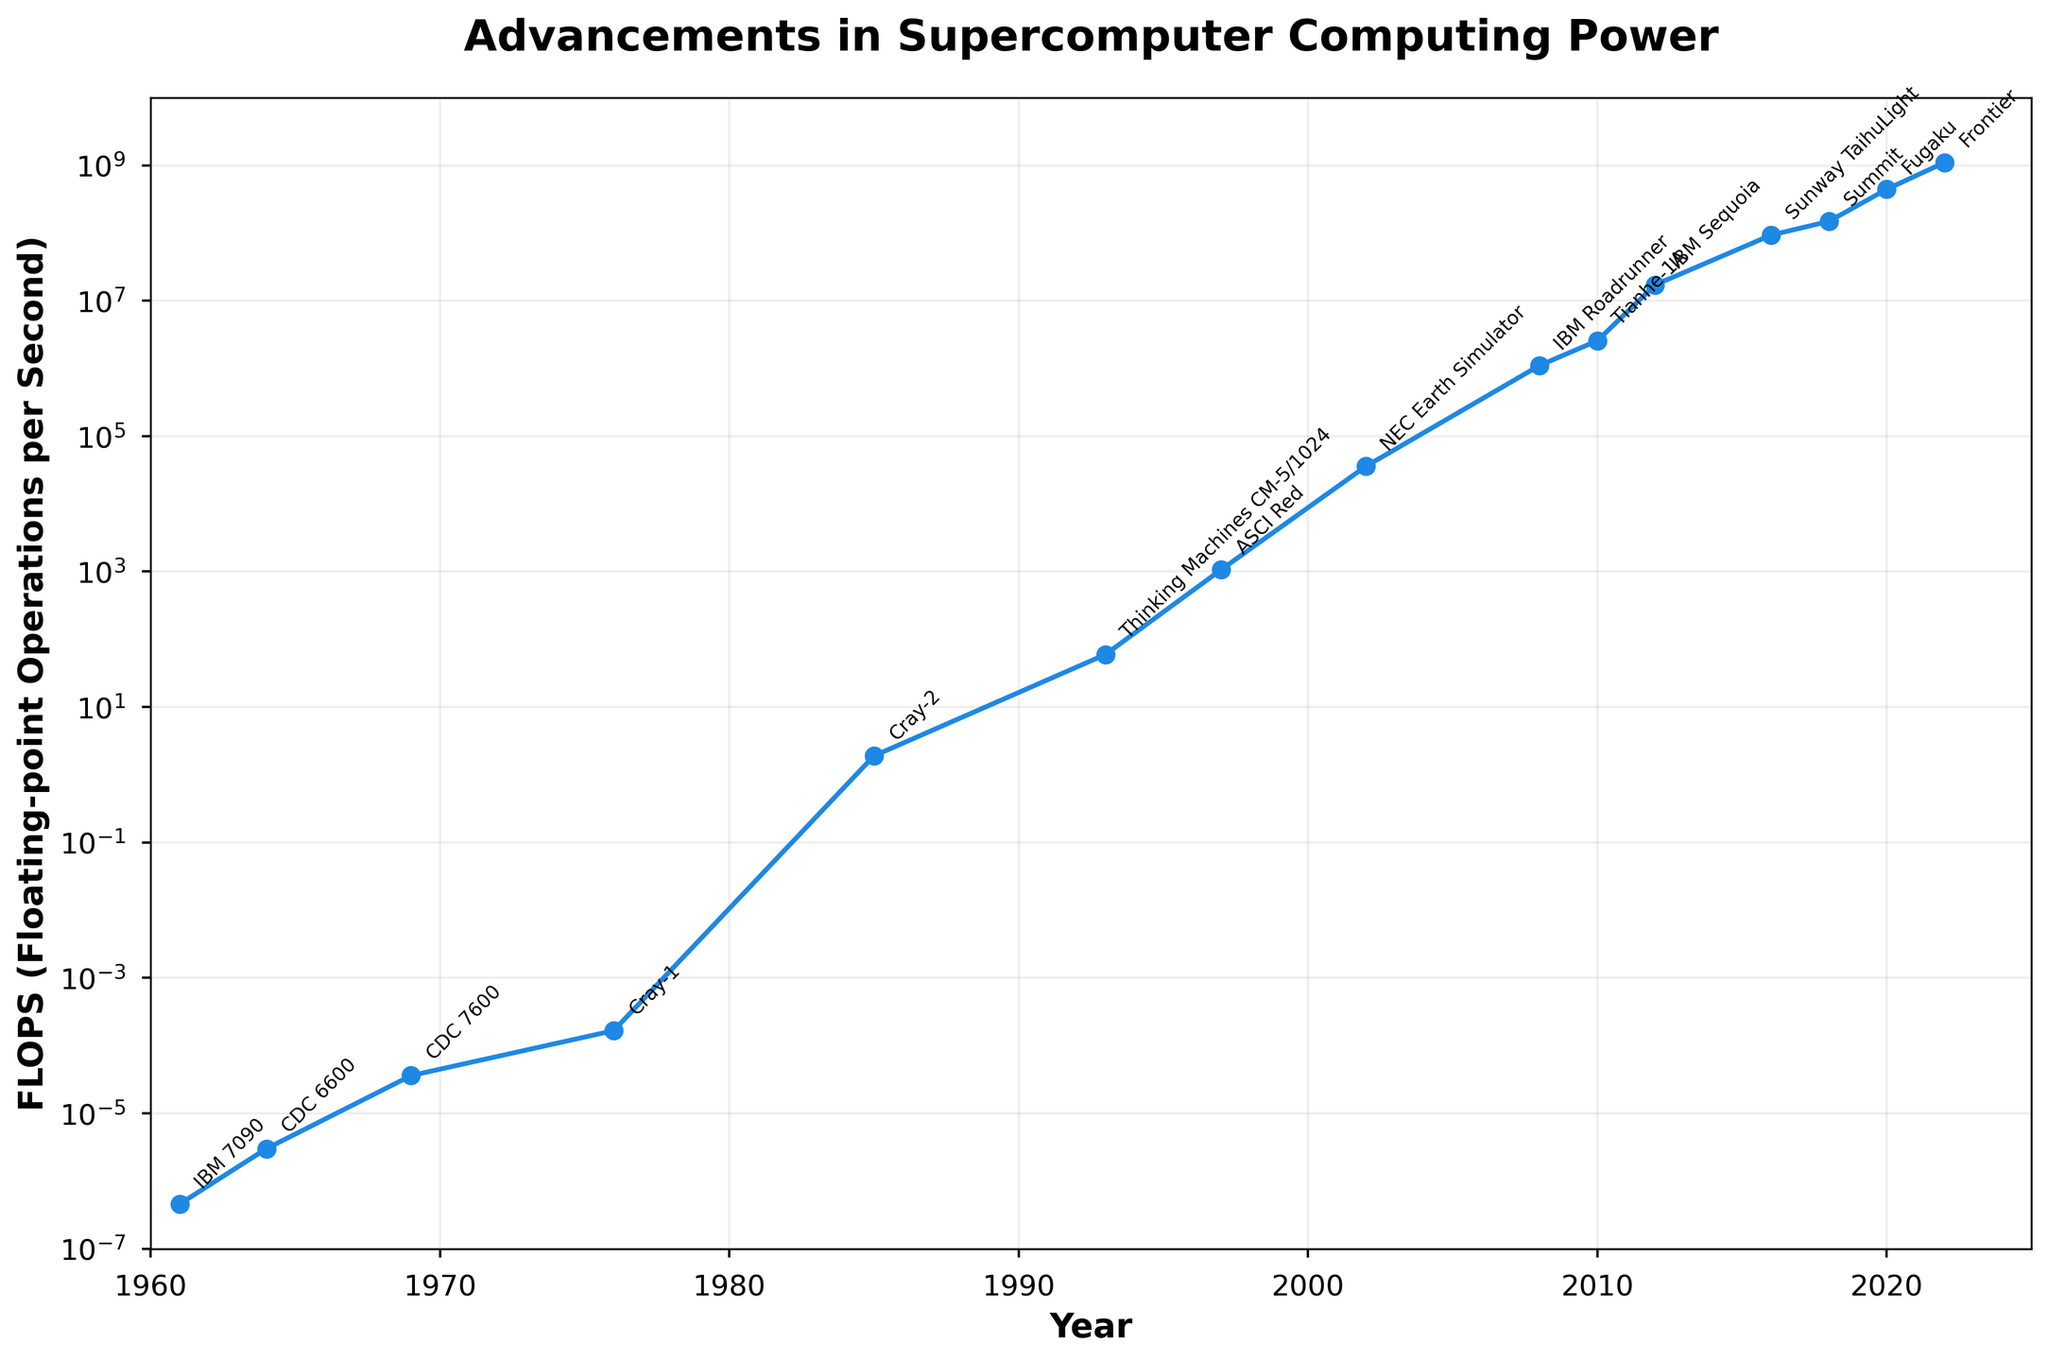What's the first supercomputer that achieved more than 1 FLOPS? By inspecting the annotated points, the Cray-2 in 1985 reached 1.9 FLOPS, making it the first supercomputer to surpass this threshold.
Answer: Cray-2 Which supercomputer shows the largest increase in FLOPS compared to its predecessor? By comparing the FLOPS values of each successive supercomputer, the largest jump is observed between IBM Sequoia (17173000 FLOPS in 2012) and Sunway TaihuLight (93014600 FLOPS in 2016), with an increase of 93014600 - 17173000 = 75841600 FLOPS.
Answer: Sunway TaihuLight What is the median year of the data points shown on the chart? The years listed are [1961, 1964, 1969, 1976, 1985, 1993, 1997, 2002, 2008, 2010, 2012, 2016, 2018, 2020, 2022]. The middle year in a sorted odd set of data is the eighth value: 2002.
Answer: 2002 Which decade saw the most rapid advancements in computing power for supercomputers? By evaluating the slope in the semilog plot, significant advancements are visible between 1980-1990 (Cray-2 to Thinking Machines CM-5/1024) and 2010-2020 (Tianhe-1A to Fugaku). Since the graphical rise between Tianhe-1A and Fugaku is steeper, it indicates the most rapid advancements.
Answer: 2010-2020 Which supercomputer was introduced in the year closest to 2000? By examining the years on the x-axis: 1997 (ASCI Red) and 2002 (NEC Earth Simulator), 2002 is closer to 2000.
Answer: NEC Earth Simulator How many years did it take for computing power to surpass 1 million FLOPS? ASCI Red reached 1068 FLOPS in 1997, and IBM Roadrunner surpassed 1 million FLOPS in 2008. Thus, it took 2008 - 1997 = 11 years.
Answer: 11 years What is the visual difference in marker size between the first supercomputer and the latest one? Both markers are circular, but the latest (Frontier) has a noticeably larger marker due to its significant FLOPS value compared to the earliest supercomputer (IBM 7090). The marker size represents the FLOPS scale.
Answer: Larger marker Which three supercomputers span approximately a 20-year period on the x-axis and show a consistent increase in FLOPS? Considering a span from around 1990 to 2010, Thinking Machines CM-5/1024 (1993), ASCI Red (1997), and IBM Roadrunner (2008) reveal a consistent increase.
Answer: Thinking Machines CM-5/1024, ASCI Red, IBM Roadrunner 